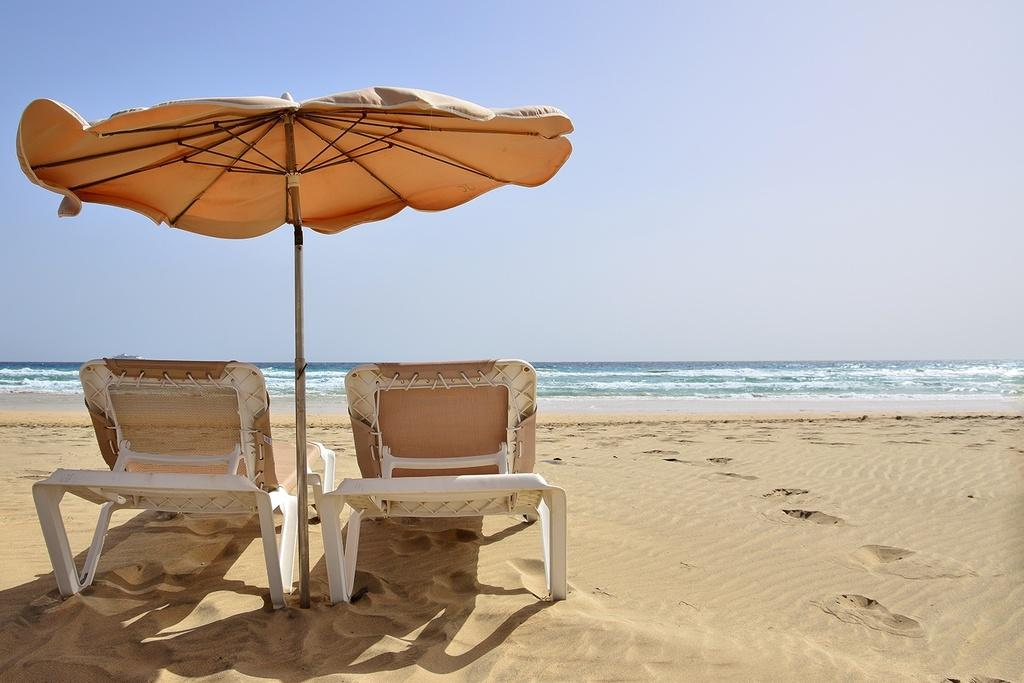How many chairs are in the image? There are two chairs in the image. What other object is present in the image besides the chairs? There is an umbrella in the image. Where are the chairs and umbrella located? The chairs and umbrella are on land in the image. What can be seen in the background of the image? There is water with some tides in the image, and the sky is visible at the top of the image. What type of record can be seen playing on the faucet in the image? There is no faucet or record present in the image. 